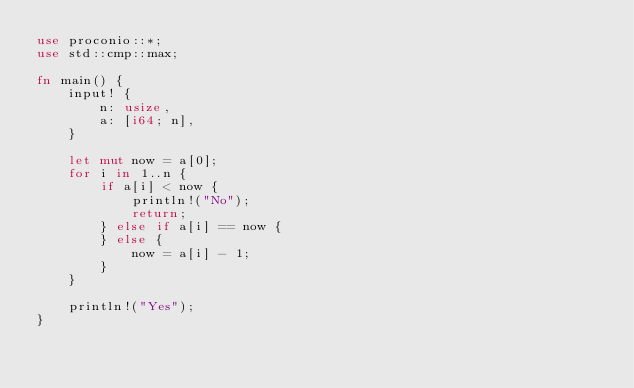Convert code to text. <code><loc_0><loc_0><loc_500><loc_500><_Rust_>use proconio::*;
use std::cmp::max;

fn main() {
    input! {
        n: usize,
        a: [i64; n],
    }

    let mut now = a[0];
    for i in 1..n {
        if a[i] < now {
            println!("No");
            return;
        } else if a[i] == now {
        } else {
            now = a[i] - 1;
        }
    }

    println!("Yes");
}
</code> 